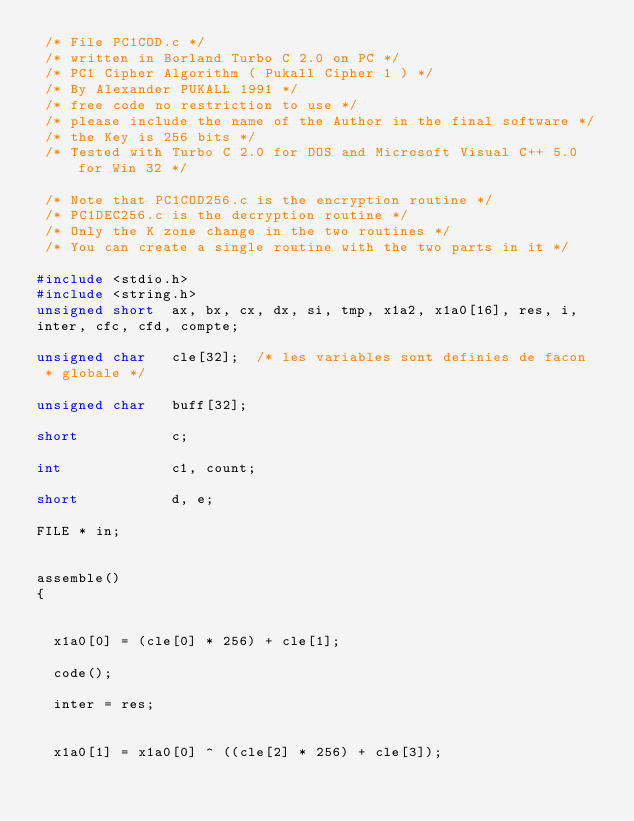Convert code to text. <code><loc_0><loc_0><loc_500><loc_500><_C_> /* File PC1COD.c */ 
 /* written in Borland Turbo C 2.0 on PC */ 
 /* PC1 Cipher Algorithm ( Pukall Cipher 1 ) */ 
 /* By Alexander PUKALL 1991 */ 
 /* free code no restriction to use */ 
 /* please include the name of the Author in the final software */ 
 /* the Key is 256 bits */ 
 /* Tested with Turbo C 2.0 for DOS and Microsoft Visual C++ 5.0 for Win 32 */ 

 /* Note that PC1COD256.c is the encryption routine */ 
 /* PC1DEC256.c is the decryption routine */ 
 /* Only the K zone change in the two routines */ 
 /* You can create a single routine with the two parts in it */ 

#include <stdio.h>
#include <string.h>
unsigned short  ax, bx, cx, dx, si, tmp, x1a2, x1a0[16], res, i,
inter, cfc, cfd, compte;

unsigned char   cle[32];	/* les variables sont definies de facon
 * globale */

unsigned char   buff[32];

short           c;

int             c1, count;

short           d, e;

FILE * in;


assemble() 
{
  
  
  x1a0[0] = (cle[0] * 256) + cle[1];
  
  code();
  
  inter = res;
  
  
  x1a0[1] = x1a0[0] ^ ((cle[2] * 256) + cle[3]);
  </code> 